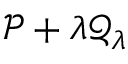Convert formula to latex. <formula><loc_0><loc_0><loc_500><loc_500>\mathcal { P } + \lambda \mathcal { Q } _ { \lambda }</formula> 